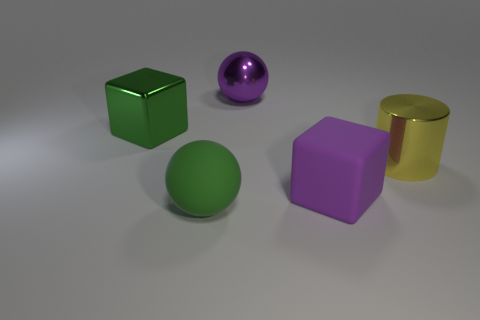How many things are either large green things or gray spheres?
Your response must be concise. 2. There is a big green thing that is made of the same material as the purple ball; what is its shape?
Provide a succinct answer. Cube. There is a rubber thing to the left of the big ball that is behind the yellow shiny cylinder; how big is it?
Offer a terse response. Large. How many small things are green objects or cyan objects?
Offer a terse response. 0. What number of other things are the same color as the large metallic block?
Your response must be concise. 1. Does the purple thing in front of the big green metal object have the same size as the ball that is in front of the purple shiny object?
Your answer should be compact. Yes. Is the material of the purple block the same as the purple object that is behind the big cylinder?
Ensure brevity in your answer.  No. Are there more cubes that are in front of the green cube than rubber balls that are right of the green sphere?
Provide a short and direct response. Yes. There is a large sphere that is behind the large sphere in front of the metallic block; what color is it?
Your response must be concise. Purple. What number of cylinders are tiny purple metallic things or large purple rubber objects?
Offer a terse response. 0. 